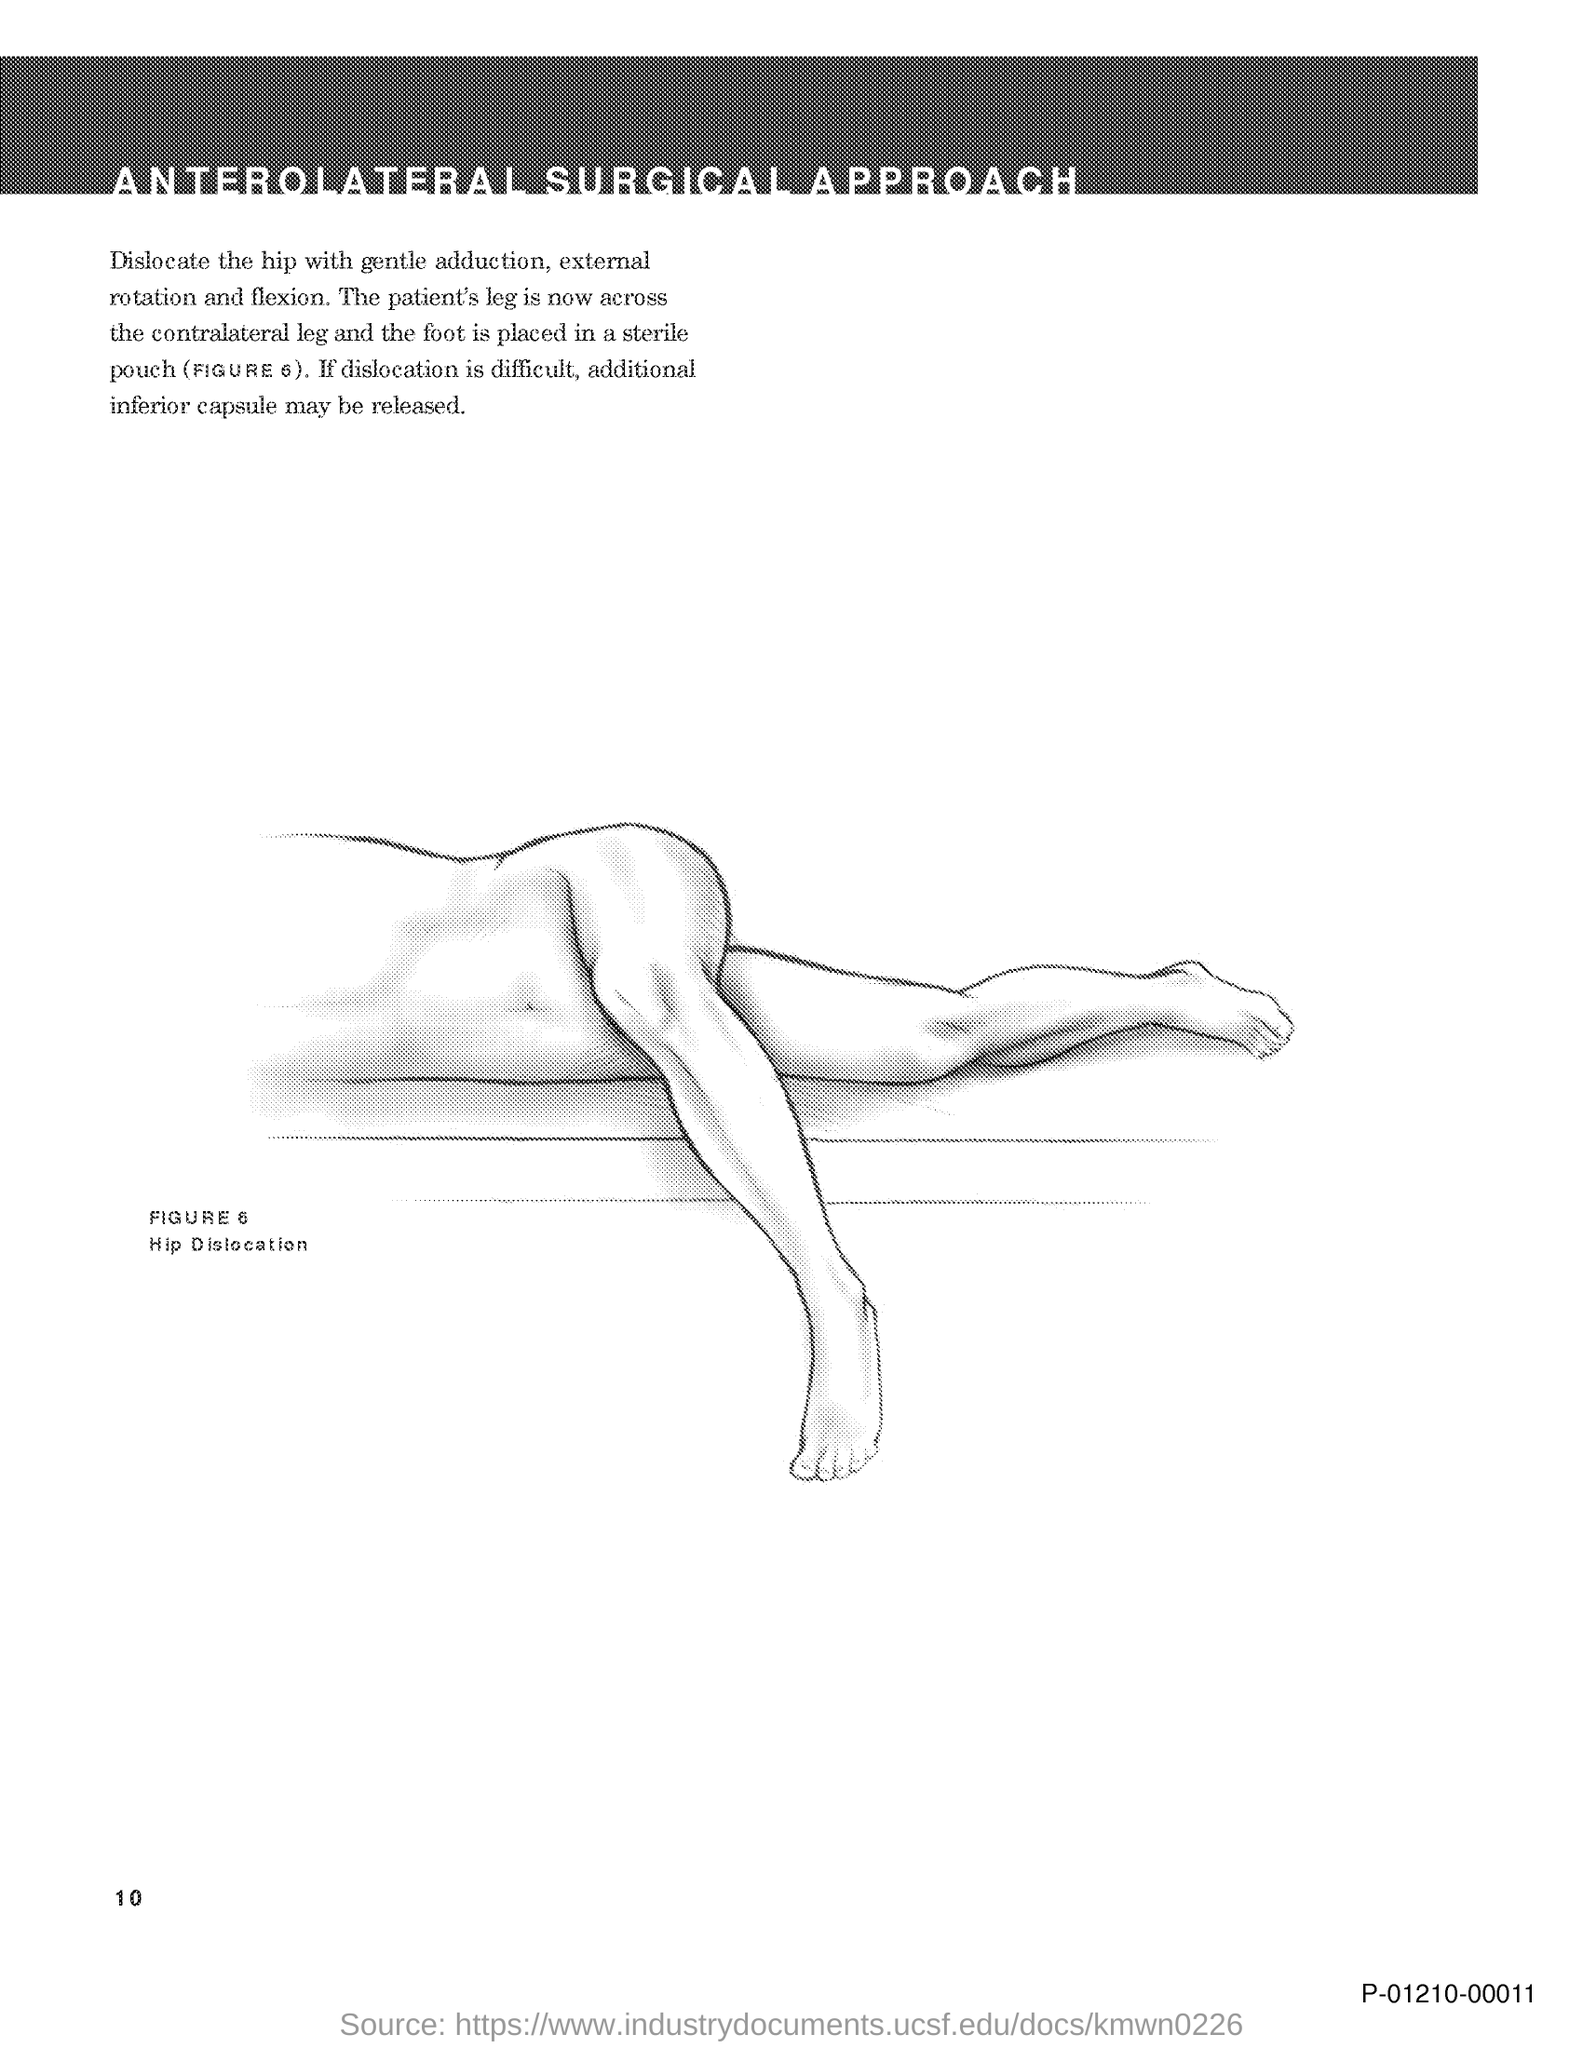What is FIGURE 6 about?
Make the answer very short. Hip Dislocation. What is the document title?
Your response must be concise. ANTEROLATERAL SURGICAL APPROACH. What is the page number on this document?
Ensure brevity in your answer.  10. 